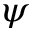Convert formula to latex. <formula><loc_0><loc_0><loc_500><loc_500>\psi</formula> 